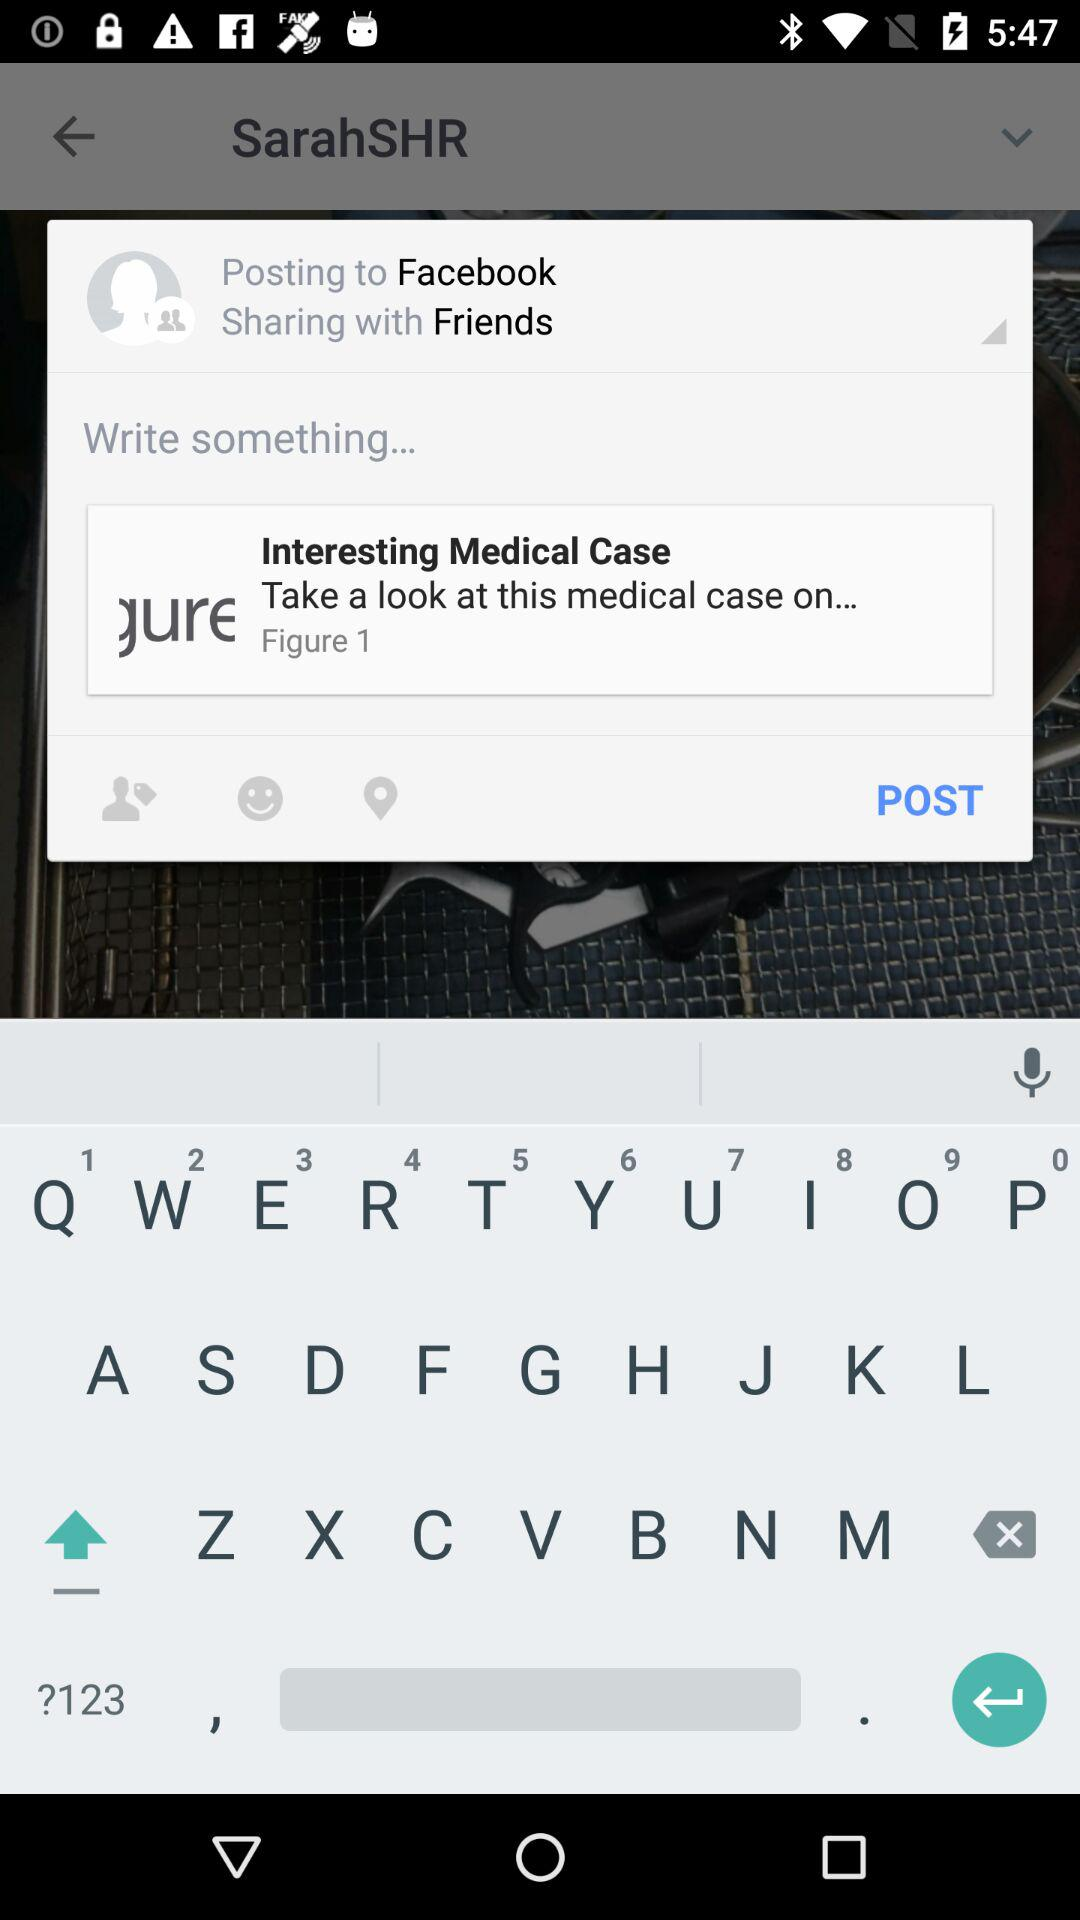What is the username? The username is "lauralee1". 